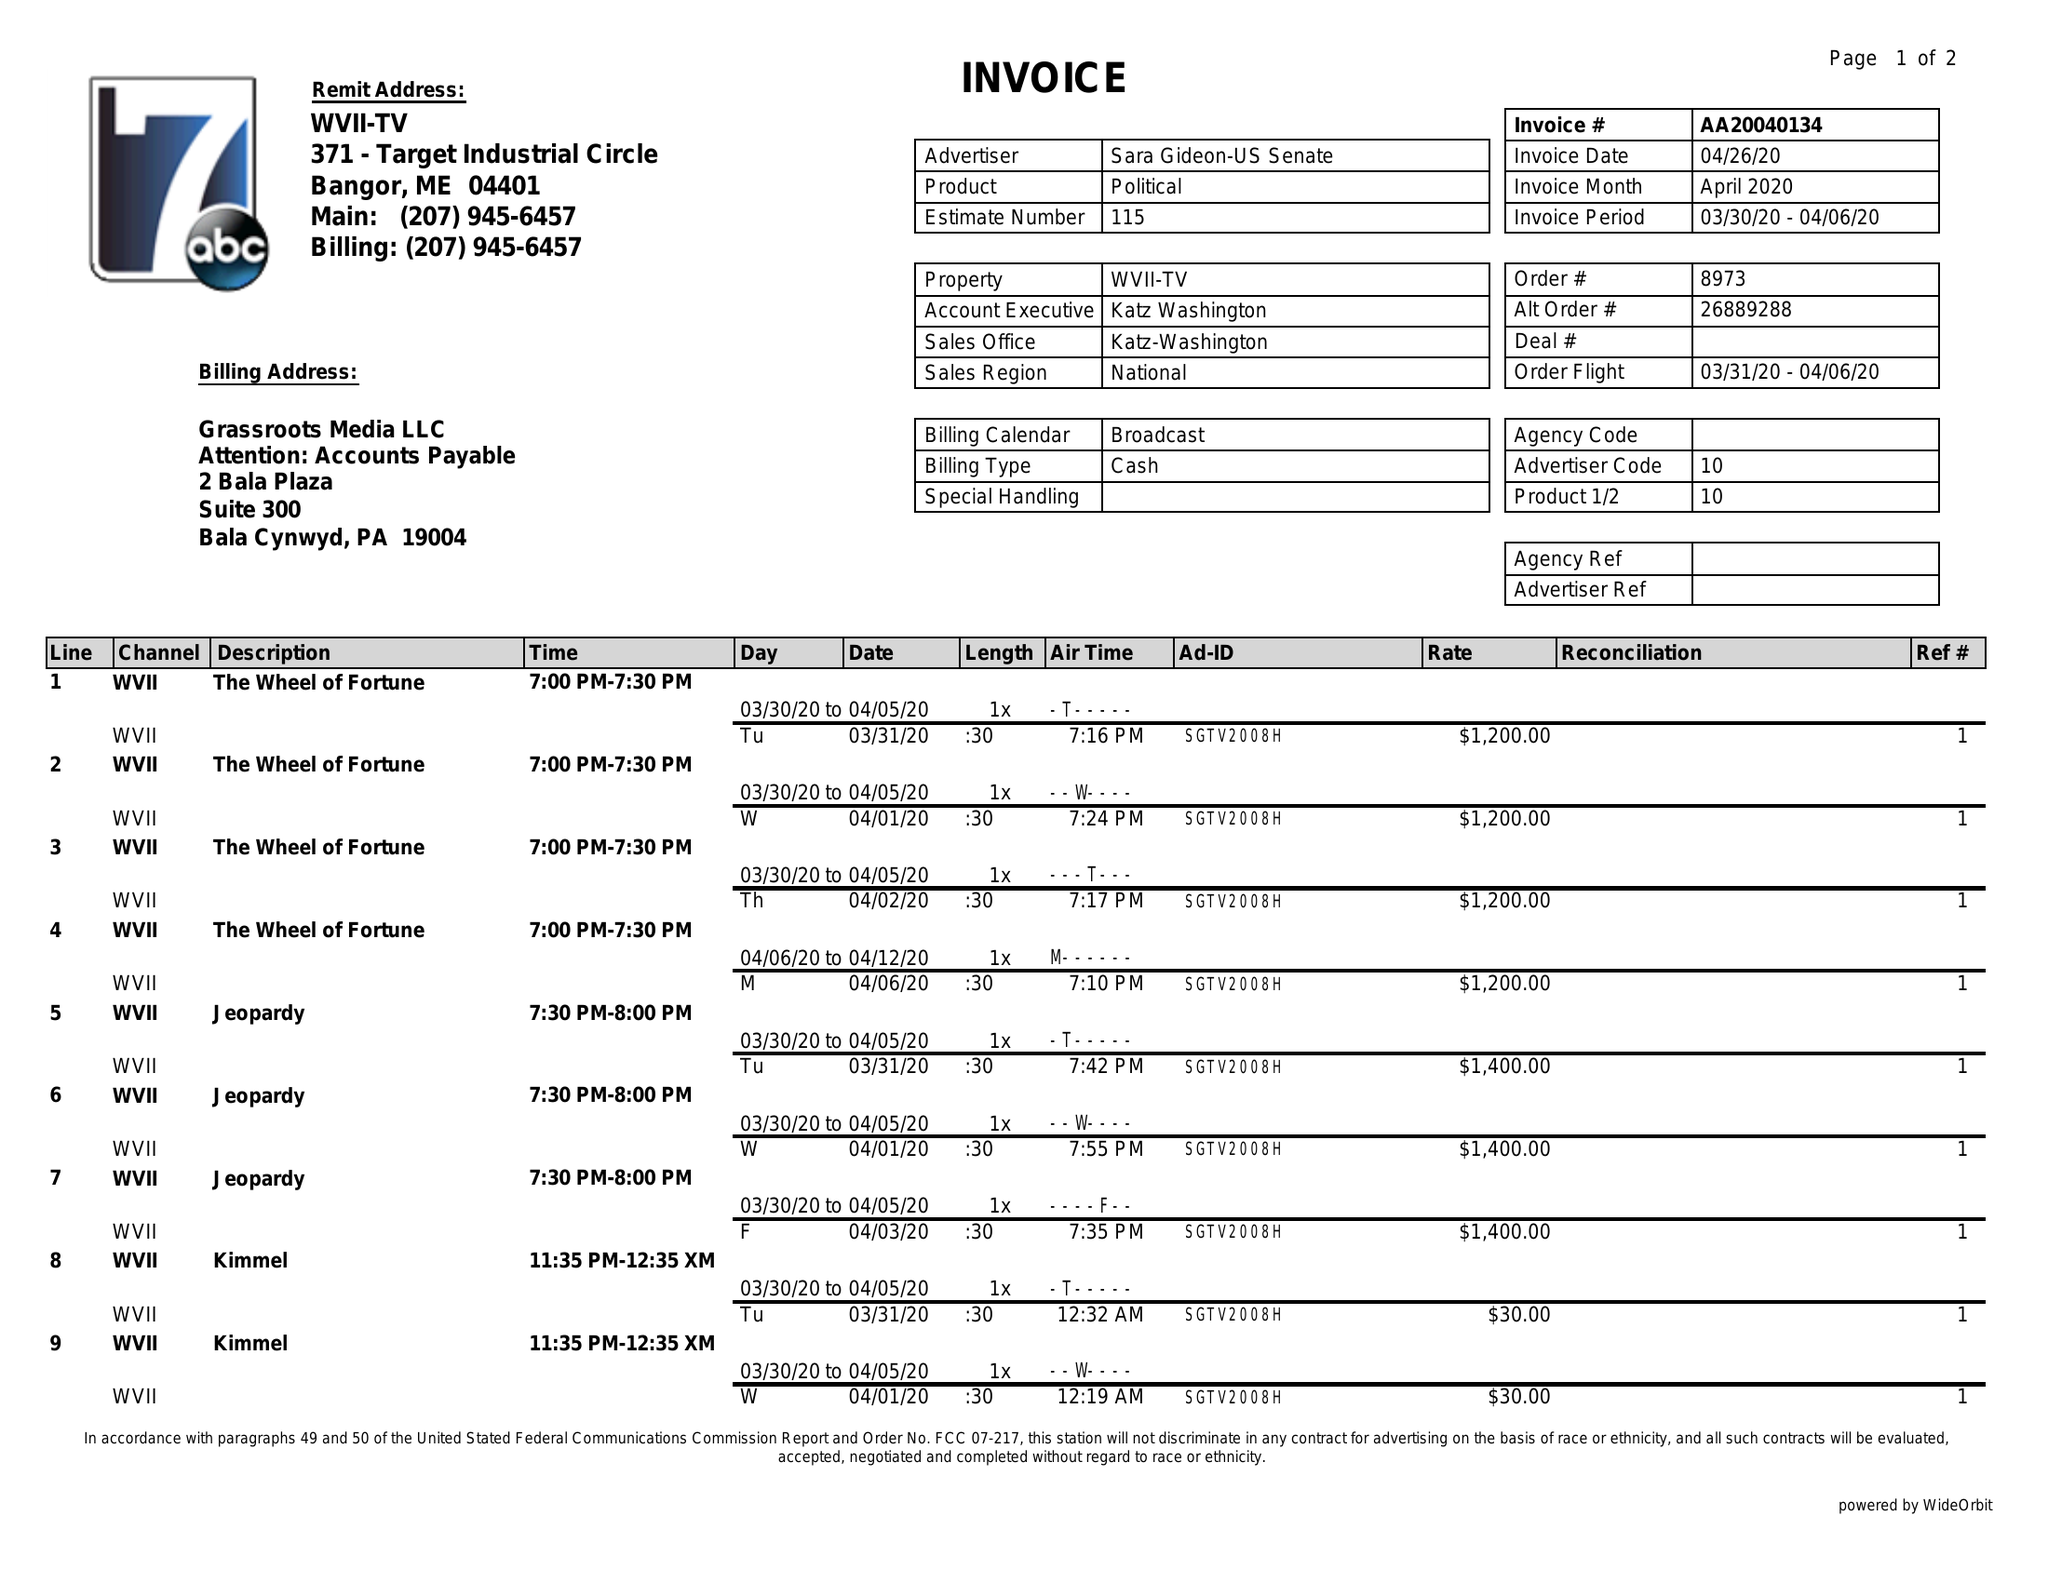What is the value for the contract_num?
Answer the question using a single word or phrase. AA20040134 